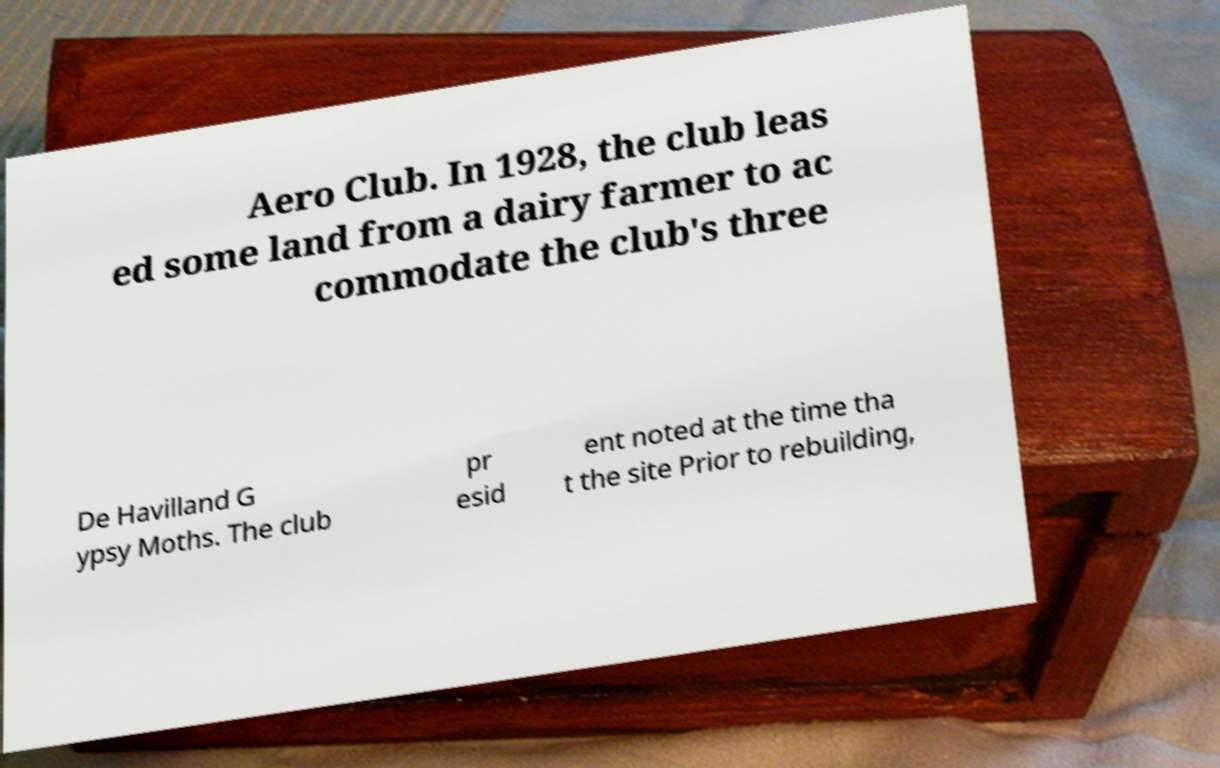I need the written content from this picture converted into text. Can you do that? Aero Club. In 1928, the club leas ed some land from a dairy farmer to ac commodate the club's three De Havilland G ypsy Moths. The club pr esid ent noted at the time tha t the site Prior to rebuilding, 